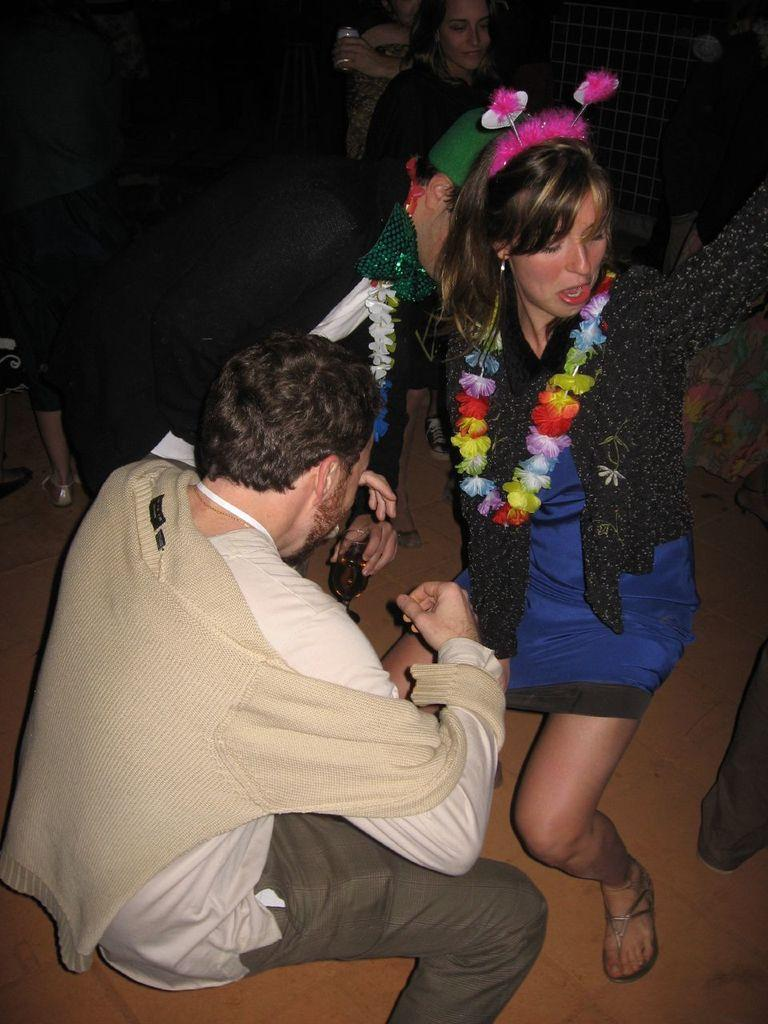Where is the man located in the image? The man is in the bottom left of the image. What is the man holding in the image? The man is holding a glass. Can you describe the woman in the image? The woman is wearing a blue and black dress. Are there any other people visible in the image? Yes, there are people visible behind the woman. What type of thread is the woman using to sew in the image? There is no thread or sewing activity visible in the image. Can you tell me the color of the stamp on the man's forehead in the image? There is no stamp present on the man's forehead in the image. 